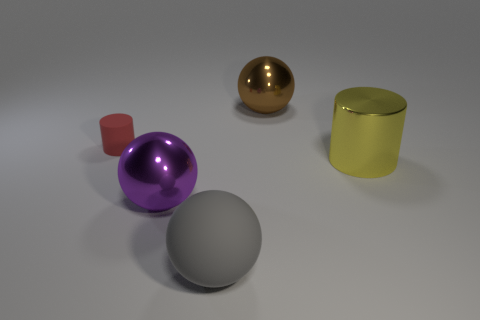Add 3 red matte cylinders. How many objects exist? 8 Subtract all balls. How many objects are left? 2 Subtract 0 purple cylinders. How many objects are left? 5 Subtract all large brown objects. Subtract all small rubber cylinders. How many objects are left? 3 Add 3 yellow cylinders. How many yellow cylinders are left? 4 Add 5 big blocks. How many big blocks exist? 5 